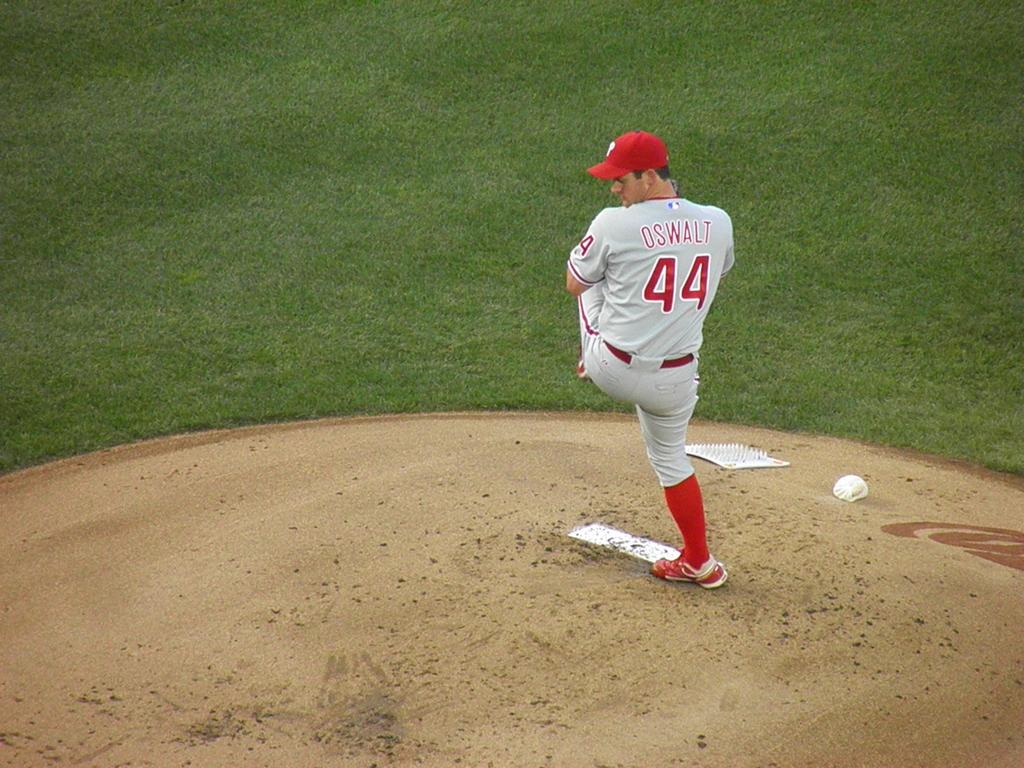<image>
Relay a brief, clear account of the picture shown. A man in a baseball uniform with the number 44 on the back. 